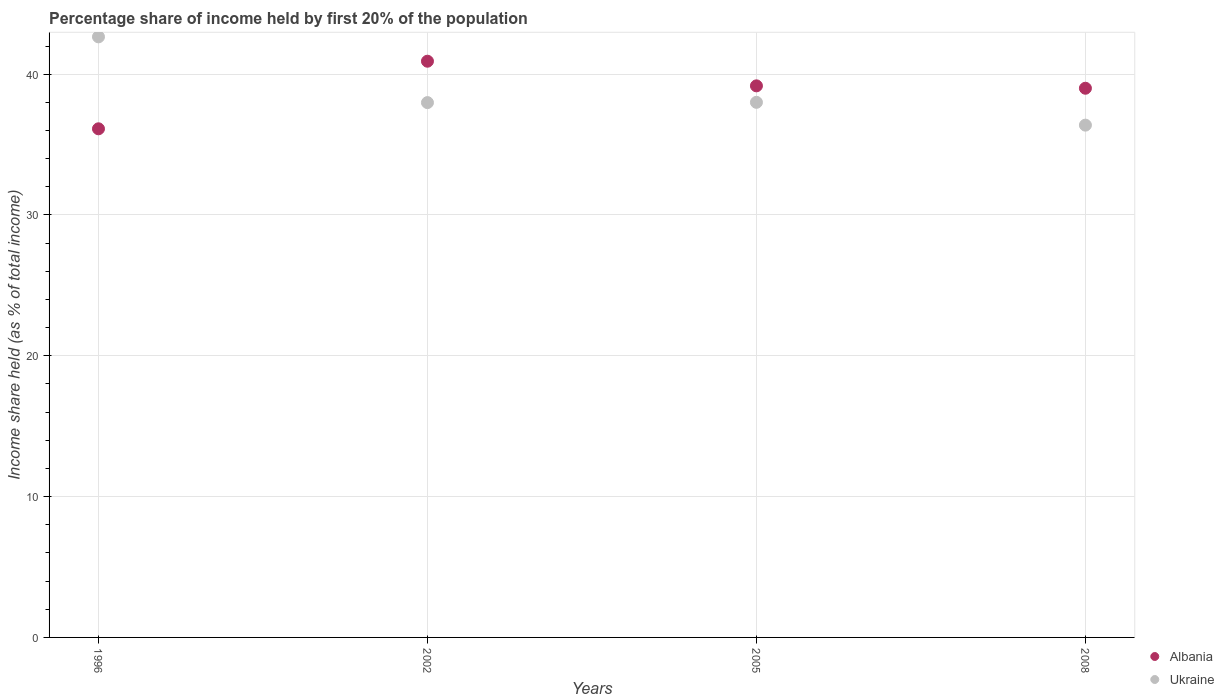What is the share of income held by first 20% of the population in Albania in 2005?
Your answer should be very brief. 39.17. Across all years, what is the maximum share of income held by first 20% of the population in Albania?
Offer a very short reply. 40.92. Across all years, what is the minimum share of income held by first 20% of the population in Albania?
Ensure brevity in your answer.  36.12. In which year was the share of income held by first 20% of the population in Albania maximum?
Provide a short and direct response. 2002. What is the total share of income held by first 20% of the population in Albania in the graph?
Provide a short and direct response. 155.21. What is the difference between the share of income held by first 20% of the population in Albania in 2002 and the share of income held by first 20% of the population in Ukraine in 2008?
Make the answer very short. 4.54. What is the average share of income held by first 20% of the population in Albania per year?
Provide a short and direct response. 38.8. In the year 2002, what is the difference between the share of income held by first 20% of the population in Ukraine and share of income held by first 20% of the population in Albania?
Make the answer very short. -2.94. What is the ratio of the share of income held by first 20% of the population in Ukraine in 2002 to that in 2008?
Provide a succinct answer. 1.04. Is the share of income held by first 20% of the population in Albania in 1996 less than that in 2005?
Make the answer very short. Yes. What is the difference between the highest and the lowest share of income held by first 20% of the population in Ukraine?
Make the answer very short. 6.27. Is the sum of the share of income held by first 20% of the population in Albania in 2005 and 2008 greater than the maximum share of income held by first 20% of the population in Ukraine across all years?
Your answer should be compact. Yes. Is the share of income held by first 20% of the population in Albania strictly less than the share of income held by first 20% of the population in Ukraine over the years?
Keep it short and to the point. No. How many dotlines are there?
Your answer should be compact. 2. What is the difference between two consecutive major ticks on the Y-axis?
Offer a very short reply. 10. Are the values on the major ticks of Y-axis written in scientific E-notation?
Provide a short and direct response. No. Does the graph contain any zero values?
Provide a succinct answer. No. Does the graph contain grids?
Your answer should be very brief. Yes. Where does the legend appear in the graph?
Offer a terse response. Bottom right. How are the legend labels stacked?
Make the answer very short. Vertical. What is the title of the graph?
Offer a terse response. Percentage share of income held by first 20% of the population. What is the label or title of the Y-axis?
Offer a terse response. Income share held (as % of total income). What is the Income share held (as % of total income) in Albania in 1996?
Ensure brevity in your answer.  36.12. What is the Income share held (as % of total income) in Ukraine in 1996?
Make the answer very short. 42.65. What is the Income share held (as % of total income) in Albania in 2002?
Your answer should be compact. 40.92. What is the Income share held (as % of total income) in Ukraine in 2002?
Provide a succinct answer. 37.98. What is the Income share held (as % of total income) of Albania in 2005?
Offer a very short reply. 39.17. What is the Income share held (as % of total income) of Ukraine in 2008?
Provide a short and direct response. 36.38. Across all years, what is the maximum Income share held (as % of total income) of Albania?
Offer a very short reply. 40.92. Across all years, what is the maximum Income share held (as % of total income) in Ukraine?
Ensure brevity in your answer.  42.65. Across all years, what is the minimum Income share held (as % of total income) of Albania?
Give a very brief answer. 36.12. Across all years, what is the minimum Income share held (as % of total income) of Ukraine?
Provide a short and direct response. 36.38. What is the total Income share held (as % of total income) in Albania in the graph?
Give a very brief answer. 155.21. What is the total Income share held (as % of total income) in Ukraine in the graph?
Provide a short and direct response. 155.01. What is the difference between the Income share held (as % of total income) of Ukraine in 1996 and that in 2002?
Your answer should be very brief. 4.67. What is the difference between the Income share held (as % of total income) of Albania in 1996 and that in 2005?
Offer a very short reply. -3.05. What is the difference between the Income share held (as % of total income) in Ukraine in 1996 and that in 2005?
Keep it short and to the point. 4.65. What is the difference between the Income share held (as % of total income) in Albania in 1996 and that in 2008?
Offer a terse response. -2.88. What is the difference between the Income share held (as % of total income) of Ukraine in 1996 and that in 2008?
Give a very brief answer. 6.27. What is the difference between the Income share held (as % of total income) of Albania in 2002 and that in 2005?
Offer a terse response. 1.75. What is the difference between the Income share held (as % of total income) in Ukraine in 2002 and that in 2005?
Give a very brief answer. -0.02. What is the difference between the Income share held (as % of total income) in Albania in 2002 and that in 2008?
Ensure brevity in your answer.  1.92. What is the difference between the Income share held (as % of total income) in Albania in 2005 and that in 2008?
Your answer should be compact. 0.17. What is the difference between the Income share held (as % of total income) of Ukraine in 2005 and that in 2008?
Your response must be concise. 1.62. What is the difference between the Income share held (as % of total income) of Albania in 1996 and the Income share held (as % of total income) of Ukraine in 2002?
Offer a very short reply. -1.86. What is the difference between the Income share held (as % of total income) of Albania in 1996 and the Income share held (as % of total income) of Ukraine in 2005?
Provide a short and direct response. -1.88. What is the difference between the Income share held (as % of total income) in Albania in 1996 and the Income share held (as % of total income) in Ukraine in 2008?
Make the answer very short. -0.26. What is the difference between the Income share held (as % of total income) of Albania in 2002 and the Income share held (as % of total income) of Ukraine in 2005?
Offer a very short reply. 2.92. What is the difference between the Income share held (as % of total income) of Albania in 2002 and the Income share held (as % of total income) of Ukraine in 2008?
Make the answer very short. 4.54. What is the difference between the Income share held (as % of total income) of Albania in 2005 and the Income share held (as % of total income) of Ukraine in 2008?
Your answer should be very brief. 2.79. What is the average Income share held (as % of total income) in Albania per year?
Keep it short and to the point. 38.8. What is the average Income share held (as % of total income) in Ukraine per year?
Your response must be concise. 38.75. In the year 1996, what is the difference between the Income share held (as % of total income) of Albania and Income share held (as % of total income) of Ukraine?
Your answer should be very brief. -6.53. In the year 2002, what is the difference between the Income share held (as % of total income) of Albania and Income share held (as % of total income) of Ukraine?
Your answer should be very brief. 2.94. In the year 2005, what is the difference between the Income share held (as % of total income) in Albania and Income share held (as % of total income) in Ukraine?
Provide a succinct answer. 1.17. In the year 2008, what is the difference between the Income share held (as % of total income) of Albania and Income share held (as % of total income) of Ukraine?
Keep it short and to the point. 2.62. What is the ratio of the Income share held (as % of total income) of Albania in 1996 to that in 2002?
Your answer should be compact. 0.88. What is the ratio of the Income share held (as % of total income) of Ukraine in 1996 to that in 2002?
Ensure brevity in your answer.  1.12. What is the ratio of the Income share held (as % of total income) of Albania in 1996 to that in 2005?
Your answer should be compact. 0.92. What is the ratio of the Income share held (as % of total income) in Ukraine in 1996 to that in 2005?
Keep it short and to the point. 1.12. What is the ratio of the Income share held (as % of total income) of Albania in 1996 to that in 2008?
Offer a terse response. 0.93. What is the ratio of the Income share held (as % of total income) of Ukraine in 1996 to that in 2008?
Offer a very short reply. 1.17. What is the ratio of the Income share held (as % of total income) in Albania in 2002 to that in 2005?
Provide a succinct answer. 1.04. What is the ratio of the Income share held (as % of total income) in Ukraine in 2002 to that in 2005?
Provide a short and direct response. 1. What is the ratio of the Income share held (as % of total income) of Albania in 2002 to that in 2008?
Give a very brief answer. 1.05. What is the ratio of the Income share held (as % of total income) in Ukraine in 2002 to that in 2008?
Your response must be concise. 1.04. What is the ratio of the Income share held (as % of total income) of Albania in 2005 to that in 2008?
Your response must be concise. 1. What is the ratio of the Income share held (as % of total income) of Ukraine in 2005 to that in 2008?
Provide a succinct answer. 1.04. What is the difference between the highest and the second highest Income share held (as % of total income) of Albania?
Your response must be concise. 1.75. What is the difference between the highest and the second highest Income share held (as % of total income) in Ukraine?
Provide a succinct answer. 4.65. What is the difference between the highest and the lowest Income share held (as % of total income) in Albania?
Make the answer very short. 4.8. What is the difference between the highest and the lowest Income share held (as % of total income) of Ukraine?
Ensure brevity in your answer.  6.27. 